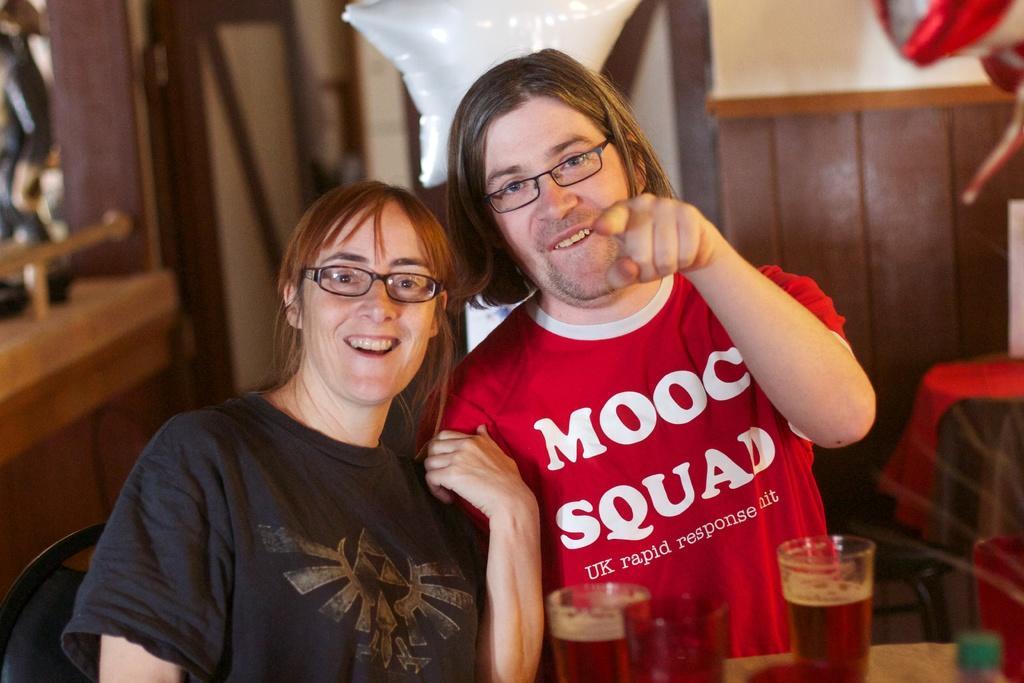In one or two sentences, can you explain what this image depicts? In this image we can see two persons smiling and wearing the spectacles, there are some glasses with drink, also we can see the chairs, tables and some other objects. 